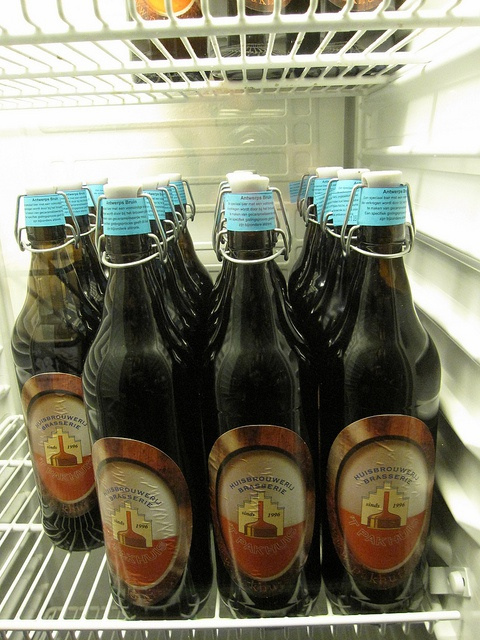Describe the objects in this image and their specific colors. I can see refrigerator in black, ivory, beige, olive, and gray tones, bottle in white, black, darkgreen, maroon, and olive tones, bottle in white, black, olive, maroon, and gray tones, bottle in white, ivory, tan, black, and beige tones, and bottle in white, black, maroon, olive, and gray tones in this image. 